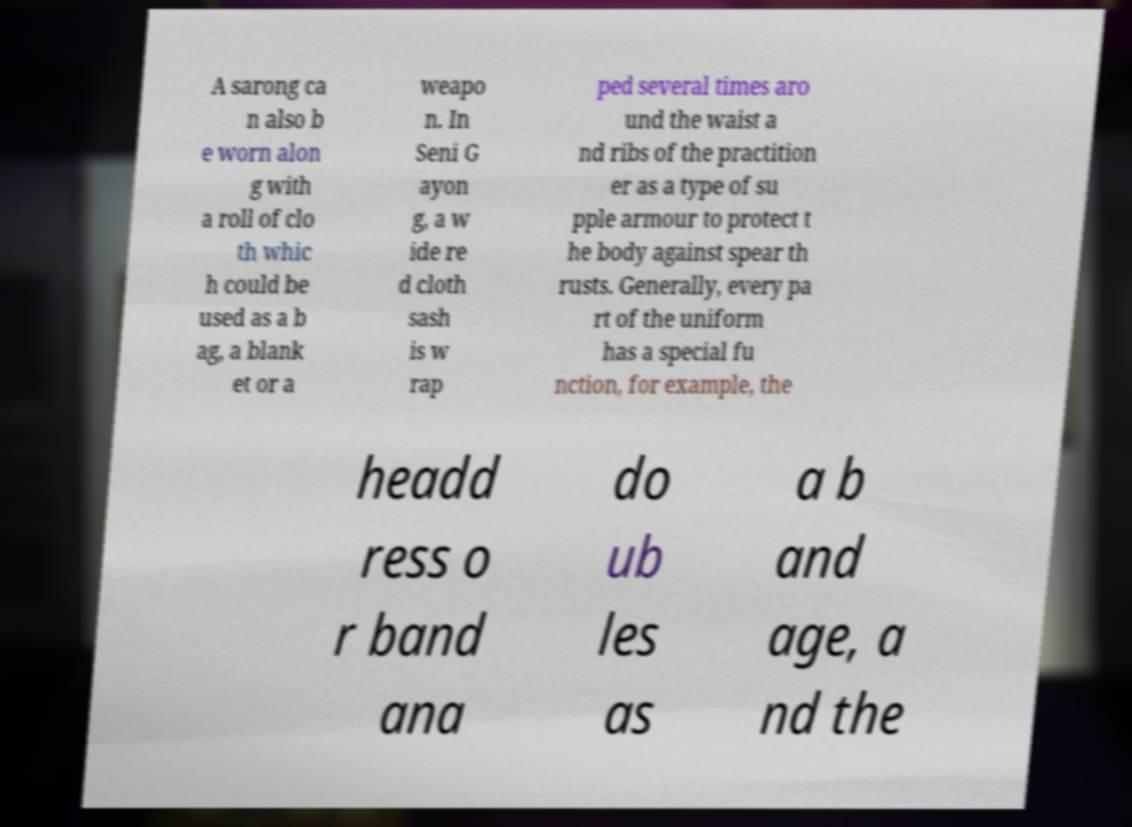There's text embedded in this image that I need extracted. Can you transcribe it verbatim? A sarong ca n also b e worn alon g with a roll of clo th whic h could be used as a b ag, a blank et or a weapo n. In Seni G ayon g, a w ide re d cloth sash is w rap ped several times aro und the waist a nd ribs of the practition er as a type of su pple armour to protect t he body against spear th rusts. Generally, every pa rt of the uniform has a special fu nction, for example, the headd ress o r band ana do ub les as a b and age, a nd the 